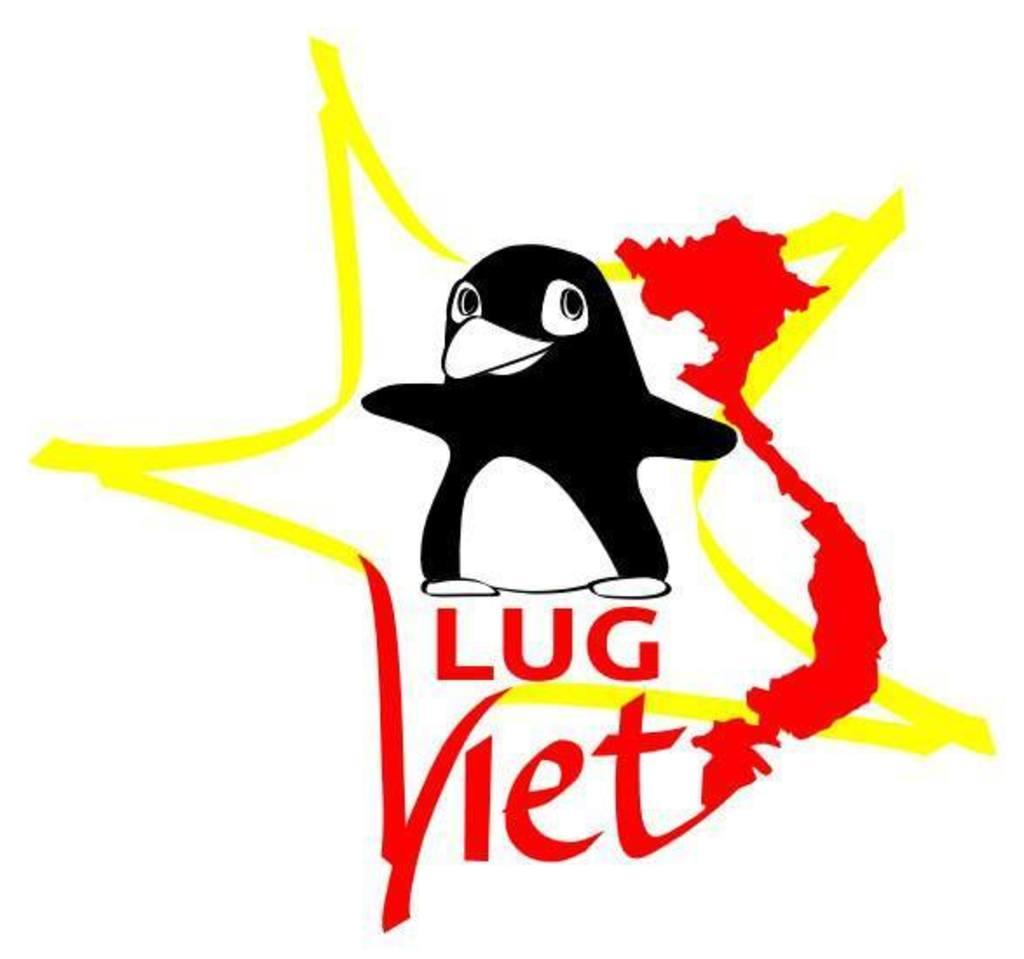What type of animal is in the image? There is a penguin in the image. What else can be seen in the image besides the penguin? There is text in the image. What color is the background of the image? The background of the image is white. What learning offer is being advertised in the image? There is no learning offer or advertisement present in the image; it features a penguin and text on a white background. 